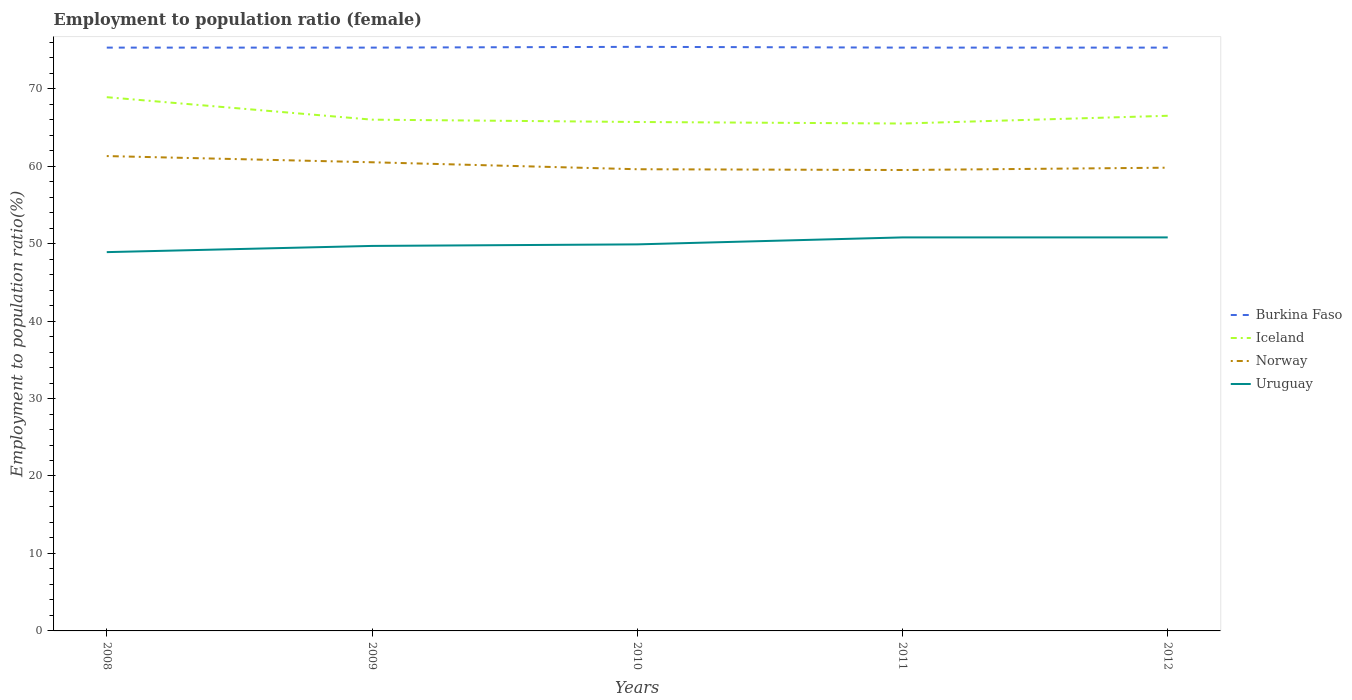How many different coloured lines are there?
Provide a short and direct response. 4. Is the number of lines equal to the number of legend labels?
Make the answer very short. Yes. Across all years, what is the maximum employment to population ratio in Uruguay?
Keep it short and to the point. 48.9. What is the total employment to population ratio in Burkina Faso in the graph?
Provide a succinct answer. 0.1. What is the difference between the highest and the second highest employment to population ratio in Norway?
Make the answer very short. 1.8. How many lines are there?
Offer a terse response. 4. How many years are there in the graph?
Your answer should be compact. 5. Where does the legend appear in the graph?
Give a very brief answer. Center right. How many legend labels are there?
Make the answer very short. 4. How are the legend labels stacked?
Your response must be concise. Vertical. What is the title of the graph?
Offer a very short reply. Employment to population ratio (female). What is the label or title of the Y-axis?
Offer a very short reply. Employment to population ratio(%). What is the Employment to population ratio(%) in Burkina Faso in 2008?
Your answer should be compact. 75.3. What is the Employment to population ratio(%) of Iceland in 2008?
Offer a terse response. 68.9. What is the Employment to population ratio(%) in Norway in 2008?
Give a very brief answer. 61.3. What is the Employment to population ratio(%) of Uruguay in 2008?
Your response must be concise. 48.9. What is the Employment to population ratio(%) in Burkina Faso in 2009?
Make the answer very short. 75.3. What is the Employment to population ratio(%) of Iceland in 2009?
Give a very brief answer. 66. What is the Employment to population ratio(%) of Norway in 2009?
Provide a short and direct response. 60.5. What is the Employment to population ratio(%) in Uruguay in 2009?
Provide a succinct answer. 49.7. What is the Employment to population ratio(%) in Burkina Faso in 2010?
Offer a terse response. 75.4. What is the Employment to population ratio(%) of Iceland in 2010?
Your answer should be very brief. 65.7. What is the Employment to population ratio(%) of Norway in 2010?
Offer a terse response. 59.6. What is the Employment to population ratio(%) of Uruguay in 2010?
Your answer should be compact. 49.9. What is the Employment to population ratio(%) in Burkina Faso in 2011?
Offer a very short reply. 75.3. What is the Employment to population ratio(%) of Iceland in 2011?
Provide a short and direct response. 65.5. What is the Employment to population ratio(%) in Norway in 2011?
Offer a terse response. 59.5. What is the Employment to population ratio(%) in Uruguay in 2011?
Make the answer very short. 50.8. What is the Employment to population ratio(%) of Burkina Faso in 2012?
Provide a short and direct response. 75.3. What is the Employment to population ratio(%) of Iceland in 2012?
Offer a very short reply. 66.5. What is the Employment to population ratio(%) of Norway in 2012?
Offer a very short reply. 59.8. What is the Employment to population ratio(%) in Uruguay in 2012?
Your response must be concise. 50.8. Across all years, what is the maximum Employment to population ratio(%) in Burkina Faso?
Make the answer very short. 75.4. Across all years, what is the maximum Employment to population ratio(%) of Iceland?
Provide a succinct answer. 68.9. Across all years, what is the maximum Employment to population ratio(%) of Norway?
Give a very brief answer. 61.3. Across all years, what is the maximum Employment to population ratio(%) in Uruguay?
Provide a short and direct response. 50.8. Across all years, what is the minimum Employment to population ratio(%) of Burkina Faso?
Offer a terse response. 75.3. Across all years, what is the minimum Employment to population ratio(%) in Iceland?
Keep it short and to the point. 65.5. Across all years, what is the minimum Employment to population ratio(%) in Norway?
Your response must be concise. 59.5. Across all years, what is the minimum Employment to population ratio(%) in Uruguay?
Provide a succinct answer. 48.9. What is the total Employment to population ratio(%) in Burkina Faso in the graph?
Your answer should be compact. 376.6. What is the total Employment to population ratio(%) of Iceland in the graph?
Offer a terse response. 332.6. What is the total Employment to population ratio(%) of Norway in the graph?
Your response must be concise. 300.7. What is the total Employment to population ratio(%) in Uruguay in the graph?
Give a very brief answer. 250.1. What is the difference between the Employment to population ratio(%) in Burkina Faso in 2008 and that in 2009?
Your response must be concise. 0. What is the difference between the Employment to population ratio(%) in Norway in 2008 and that in 2011?
Provide a short and direct response. 1.8. What is the difference between the Employment to population ratio(%) of Uruguay in 2008 and that in 2011?
Your answer should be very brief. -1.9. What is the difference between the Employment to population ratio(%) in Iceland in 2008 and that in 2012?
Ensure brevity in your answer.  2.4. What is the difference between the Employment to population ratio(%) of Uruguay in 2008 and that in 2012?
Your response must be concise. -1.9. What is the difference between the Employment to population ratio(%) of Norway in 2009 and that in 2010?
Offer a very short reply. 0.9. What is the difference between the Employment to population ratio(%) of Burkina Faso in 2009 and that in 2011?
Your response must be concise. 0. What is the difference between the Employment to population ratio(%) of Iceland in 2009 and that in 2011?
Keep it short and to the point. 0.5. What is the difference between the Employment to population ratio(%) of Norway in 2009 and that in 2011?
Give a very brief answer. 1. What is the difference between the Employment to population ratio(%) in Uruguay in 2009 and that in 2012?
Your answer should be very brief. -1.1. What is the difference between the Employment to population ratio(%) of Burkina Faso in 2010 and that in 2011?
Provide a succinct answer. 0.1. What is the difference between the Employment to population ratio(%) of Iceland in 2010 and that in 2011?
Provide a succinct answer. 0.2. What is the difference between the Employment to population ratio(%) of Norway in 2010 and that in 2011?
Your response must be concise. 0.1. What is the difference between the Employment to population ratio(%) of Uruguay in 2010 and that in 2011?
Provide a short and direct response. -0.9. What is the difference between the Employment to population ratio(%) of Burkina Faso in 2010 and that in 2012?
Give a very brief answer. 0.1. What is the difference between the Employment to population ratio(%) in Iceland in 2010 and that in 2012?
Ensure brevity in your answer.  -0.8. What is the difference between the Employment to population ratio(%) in Norway in 2010 and that in 2012?
Your response must be concise. -0.2. What is the difference between the Employment to population ratio(%) in Iceland in 2011 and that in 2012?
Give a very brief answer. -1. What is the difference between the Employment to population ratio(%) of Norway in 2011 and that in 2012?
Offer a terse response. -0.3. What is the difference between the Employment to population ratio(%) of Uruguay in 2011 and that in 2012?
Give a very brief answer. 0. What is the difference between the Employment to population ratio(%) in Burkina Faso in 2008 and the Employment to population ratio(%) in Iceland in 2009?
Keep it short and to the point. 9.3. What is the difference between the Employment to population ratio(%) in Burkina Faso in 2008 and the Employment to population ratio(%) in Norway in 2009?
Ensure brevity in your answer.  14.8. What is the difference between the Employment to population ratio(%) in Burkina Faso in 2008 and the Employment to population ratio(%) in Uruguay in 2009?
Your response must be concise. 25.6. What is the difference between the Employment to population ratio(%) in Iceland in 2008 and the Employment to population ratio(%) in Uruguay in 2009?
Make the answer very short. 19.2. What is the difference between the Employment to population ratio(%) in Burkina Faso in 2008 and the Employment to population ratio(%) in Norway in 2010?
Give a very brief answer. 15.7. What is the difference between the Employment to population ratio(%) in Burkina Faso in 2008 and the Employment to population ratio(%) in Uruguay in 2010?
Give a very brief answer. 25.4. What is the difference between the Employment to population ratio(%) of Iceland in 2008 and the Employment to population ratio(%) of Norway in 2010?
Provide a succinct answer. 9.3. What is the difference between the Employment to population ratio(%) in Iceland in 2008 and the Employment to population ratio(%) in Uruguay in 2010?
Offer a terse response. 19. What is the difference between the Employment to population ratio(%) in Norway in 2008 and the Employment to population ratio(%) in Uruguay in 2010?
Offer a terse response. 11.4. What is the difference between the Employment to population ratio(%) in Burkina Faso in 2008 and the Employment to population ratio(%) in Norway in 2011?
Make the answer very short. 15.8. What is the difference between the Employment to population ratio(%) in Burkina Faso in 2008 and the Employment to population ratio(%) in Uruguay in 2011?
Your answer should be very brief. 24.5. What is the difference between the Employment to population ratio(%) of Iceland in 2008 and the Employment to population ratio(%) of Uruguay in 2011?
Your response must be concise. 18.1. What is the difference between the Employment to population ratio(%) in Norway in 2008 and the Employment to population ratio(%) in Uruguay in 2011?
Ensure brevity in your answer.  10.5. What is the difference between the Employment to population ratio(%) in Burkina Faso in 2008 and the Employment to population ratio(%) in Iceland in 2012?
Make the answer very short. 8.8. What is the difference between the Employment to population ratio(%) of Burkina Faso in 2008 and the Employment to population ratio(%) of Uruguay in 2012?
Make the answer very short. 24.5. What is the difference between the Employment to population ratio(%) of Iceland in 2008 and the Employment to population ratio(%) of Uruguay in 2012?
Offer a terse response. 18.1. What is the difference between the Employment to population ratio(%) in Burkina Faso in 2009 and the Employment to population ratio(%) in Norway in 2010?
Keep it short and to the point. 15.7. What is the difference between the Employment to population ratio(%) in Burkina Faso in 2009 and the Employment to population ratio(%) in Uruguay in 2010?
Offer a terse response. 25.4. What is the difference between the Employment to population ratio(%) of Iceland in 2009 and the Employment to population ratio(%) of Uruguay in 2010?
Your response must be concise. 16.1. What is the difference between the Employment to population ratio(%) of Norway in 2009 and the Employment to population ratio(%) of Uruguay in 2010?
Provide a short and direct response. 10.6. What is the difference between the Employment to population ratio(%) of Iceland in 2009 and the Employment to population ratio(%) of Uruguay in 2011?
Offer a terse response. 15.2. What is the difference between the Employment to population ratio(%) in Burkina Faso in 2009 and the Employment to population ratio(%) in Iceland in 2012?
Your answer should be compact. 8.8. What is the difference between the Employment to population ratio(%) in Burkina Faso in 2009 and the Employment to population ratio(%) in Uruguay in 2012?
Make the answer very short. 24.5. What is the difference between the Employment to population ratio(%) in Iceland in 2009 and the Employment to population ratio(%) in Norway in 2012?
Your response must be concise. 6.2. What is the difference between the Employment to population ratio(%) in Norway in 2009 and the Employment to population ratio(%) in Uruguay in 2012?
Your answer should be compact. 9.7. What is the difference between the Employment to population ratio(%) in Burkina Faso in 2010 and the Employment to population ratio(%) in Uruguay in 2011?
Offer a terse response. 24.6. What is the difference between the Employment to population ratio(%) of Iceland in 2010 and the Employment to population ratio(%) of Norway in 2011?
Give a very brief answer. 6.2. What is the difference between the Employment to population ratio(%) of Burkina Faso in 2010 and the Employment to population ratio(%) of Iceland in 2012?
Provide a short and direct response. 8.9. What is the difference between the Employment to population ratio(%) of Burkina Faso in 2010 and the Employment to population ratio(%) of Uruguay in 2012?
Your answer should be compact. 24.6. What is the difference between the Employment to population ratio(%) of Iceland in 2010 and the Employment to population ratio(%) of Norway in 2012?
Provide a succinct answer. 5.9. What is the difference between the Employment to population ratio(%) of Burkina Faso in 2011 and the Employment to population ratio(%) of Norway in 2012?
Offer a terse response. 15.5. What is the difference between the Employment to population ratio(%) in Iceland in 2011 and the Employment to population ratio(%) in Norway in 2012?
Give a very brief answer. 5.7. What is the difference between the Employment to population ratio(%) in Norway in 2011 and the Employment to population ratio(%) in Uruguay in 2012?
Keep it short and to the point. 8.7. What is the average Employment to population ratio(%) in Burkina Faso per year?
Make the answer very short. 75.32. What is the average Employment to population ratio(%) of Iceland per year?
Your response must be concise. 66.52. What is the average Employment to population ratio(%) in Norway per year?
Offer a very short reply. 60.14. What is the average Employment to population ratio(%) of Uruguay per year?
Make the answer very short. 50.02. In the year 2008, what is the difference between the Employment to population ratio(%) of Burkina Faso and Employment to population ratio(%) of Iceland?
Your response must be concise. 6.4. In the year 2008, what is the difference between the Employment to population ratio(%) of Burkina Faso and Employment to population ratio(%) of Uruguay?
Make the answer very short. 26.4. In the year 2008, what is the difference between the Employment to population ratio(%) of Norway and Employment to population ratio(%) of Uruguay?
Ensure brevity in your answer.  12.4. In the year 2009, what is the difference between the Employment to population ratio(%) in Burkina Faso and Employment to population ratio(%) in Iceland?
Make the answer very short. 9.3. In the year 2009, what is the difference between the Employment to population ratio(%) in Burkina Faso and Employment to population ratio(%) in Uruguay?
Make the answer very short. 25.6. In the year 2009, what is the difference between the Employment to population ratio(%) of Iceland and Employment to population ratio(%) of Uruguay?
Keep it short and to the point. 16.3. In the year 2009, what is the difference between the Employment to population ratio(%) in Norway and Employment to population ratio(%) in Uruguay?
Keep it short and to the point. 10.8. In the year 2010, what is the difference between the Employment to population ratio(%) in Burkina Faso and Employment to population ratio(%) in Iceland?
Give a very brief answer. 9.7. In the year 2010, what is the difference between the Employment to population ratio(%) of Burkina Faso and Employment to population ratio(%) of Norway?
Ensure brevity in your answer.  15.8. In the year 2010, what is the difference between the Employment to population ratio(%) in Burkina Faso and Employment to population ratio(%) in Uruguay?
Make the answer very short. 25.5. In the year 2010, what is the difference between the Employment to population ratio(%) in Iceland and Employment to population ratio(%) in Norway?
Your response must be concise. 6.1. In the year 2010, what is the difference between the Employment to population ratio(%) in Iceland and Employment to population ratio(%) in Uruguay?
Give a very brief answer. 15.8. In the year 2010, what is the difference between the Employment to population ratio(%) of Norway and Employment to population ratio(%) of Uruguay?
Provide a succinct answer. 9.7. In the year 2011, what is the difference between the Employment to population ratio(%) of Burkina Faso and Employment to population ratio(%) of Iceland?
Ensure brevity in your answer.  9.8. In the year 2011, what is the difference between the Employment to population ratio(%) of Norway and Employment to population ratio(%) of Uruguay?
Keep it short and to the point. 8.7. In the year 2012, what is the difference between the Employment to population ratio(%) of Burkina Faso and Employment to population ratio(%) of Norway?
Your answer should be very brief. 15.5. In the year 2012, what is the difference between the Employment to population ratio(%) of Iceland and Employment to population ratio(%) of Uruguay?
Your answer should be compact. 15.7. In the year 2012, what is the difference between the Employment to population ratio(%) of Norway and Employment to population ratio(%) of Uruguay?
Provide a succinct answer. 9. What is the ratio of the Employment to population ratio(%) in Burkina Faso in 2008 to that in 2009?
Offer a terse response. 1. What is the ratio of the Employment to population ratio(%) of Iceland in 2008 to that in 2009?
Offer a terse response. 1.04. What is the ratio of the Employment to population ratio(%) in Norway in 2008 to that in 2009?
Provide a short and direct response. 1.01. What is the ratio of the Employment to population ratio(%) of Uruguay in 2008 to that in 2009?
Provide a succinct answer. 0.98. What is the ratio of the Employment to population ratio(%) of Iceland in 2008 to that in 2010?
Your answer should be very brief. 1.05. What is the ratio of the Employment to population ratio(%) in Norway in 2008 to that in 2010?
Your answer should be compact. 1.03. What is the ratio of the Employment to population ratio(%) of Burkina Faso in 2008 to that in 2011?
Your response must be concise. 1. What is the ratio of the Employment to population ratio(%) in Iceland in 2008 to that in 2011?
Make the answer very short. 1.05. What is the ratio of the Employment to population ratio(%) of Norway in 2008 to that in 2011?
Make the answer very short. 1.03. What is the ratio of the Employment to population ratio(%) in Uruguay in 2008 to that in 2011?
Offer a terse response. 0.96. What is the ratio of the Employment to population ratio(%) in Iceland in 2008 to that in 2012?
Your response must be concise. 1.04. What is the ratio of the Employment to population ratio(%) in Norway in 2008 to that in 2012?
Offer a very short reply. 1.03. What is the ratio of the Employment to population ratio(%) of Uruguay in 2008 to that in 2012?
Provide a succinct answer. 0.96. What is the ratio of the Employment to population ratio(%) in Norway in 2009 to that in 2010?
Provide a succinct answer. 1.02. What is the ratio of the Employment to population ratio(%) of Burkina Faso in 2009 to that in 2011?
Offer a very short reply. 1. What is the ratio of the Employment to population ratio(%) in Iceland in 2009 to that in 2011?
Keep it short and to the point. 1.01. What is the ratio of the Employment to population ratio(%) of Norway in 2009 to that in 2011?
Offer a very short reply. 1.02. What is the ratio of the Employment to population ratio(%) of Uruguay in 2009 to that in 2011?
Your answer should be compact. 0.98. What is the ratio of the Employment to population ratio(%) in Burkina Faso in 2009 to that in 2012?
Offer a very short reply. 1. What is the ratio of the Employment to population ratio(%) in Norway in 2009 to that in 2012?
Offer a terse response. 1.01. What is the ratio of the Employment to population ratio(%) of Uruguay in 2009 to that in 2012?
Offer a terse response. 0.98. What is the ratio of the Employment to population ratio(%) of Burkina Faso in 2010 to that in 2011?
Keep it short and to the point. 1. What is the ratio of the Employment to population ratio(%) of Uruguay in 2010 to that in 2011?
Provide a succinct answer. 0.98. What is the ratio of the Employment to population ratio(%) of Uruguay in 2010 to that in 2012?
Provide a short and direct response. 0.98. What is the ratio of the Employment to population ratio(%) of Burkina Faso in 2011 to that in 2012?
Offer a very short reply. 1. What is the ratio of the Employment to population ratio(%) in Iceland in 2011 to that in 2012?
Your response must be concise. 0.98. What is the ratio of the Employment to population ratio(%) in Uruguay in 2011 to that in 2012?
Ensure brevity in your answer.  1. What is the difference between the highest and the second highest Employment to population ratio(%) in Burkina Faso?
Your answer should be compact. 0.1. What is the difference between the highest and the second highest Employment to population ratio(%) in Norway?
Offer a terse response. 0.8. What is the difference between the highest and the second highest Employment to population ratio(%) of Uruguay?
Your response must be concise. 0. What is the difference between the highest and the lowest Employment to population ratio(%) in Burkina Faso?
Make the answer very short. 0.1. What is the difference between the highest and the lowest Employment to population ratio(%) in Iceland?
Your response must be concise. 3.4. 